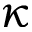Convert formula to latex. <formula><loc_0><loc_0><loc_500><loc_500>\kappa</formula> 